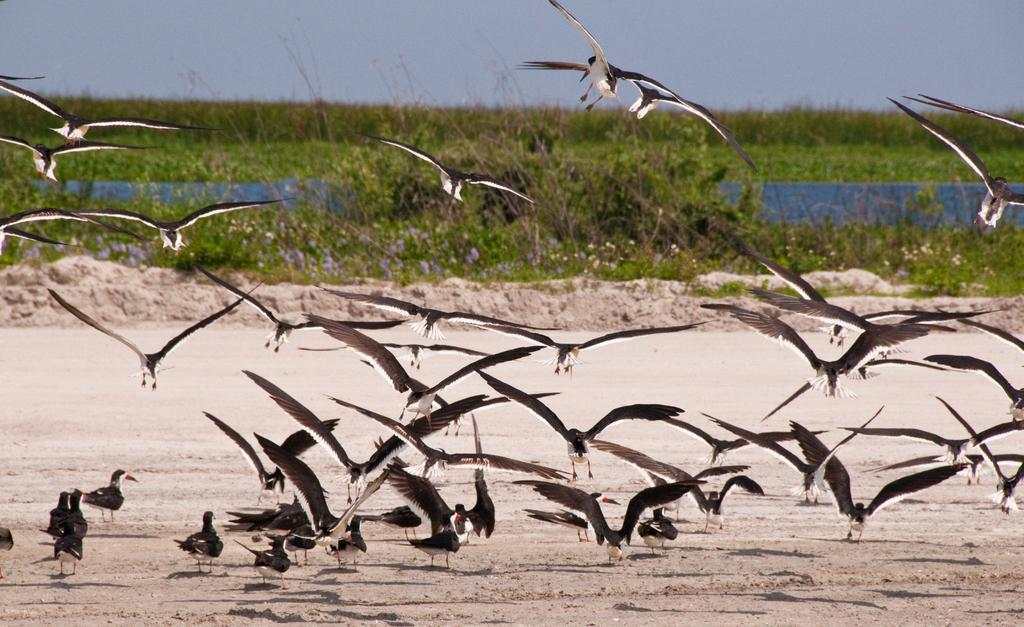What type of animals can be seen in the image? There are birds in the air and on the sand in the image. What can be seen in the background of the image? There are trees, plants, water, and the sky visible in the background of the image. Can you describe the environment in the image? The image features birds in a natural setting with trees, plants, water, and sand. What type of pets are visible in the image? There are no pets visible in the image; it features birds in a natural setting. What type of veil can be seen on the birds in the image? There is no veil present on the birds in the image; they are simply birds in their natural environment. 